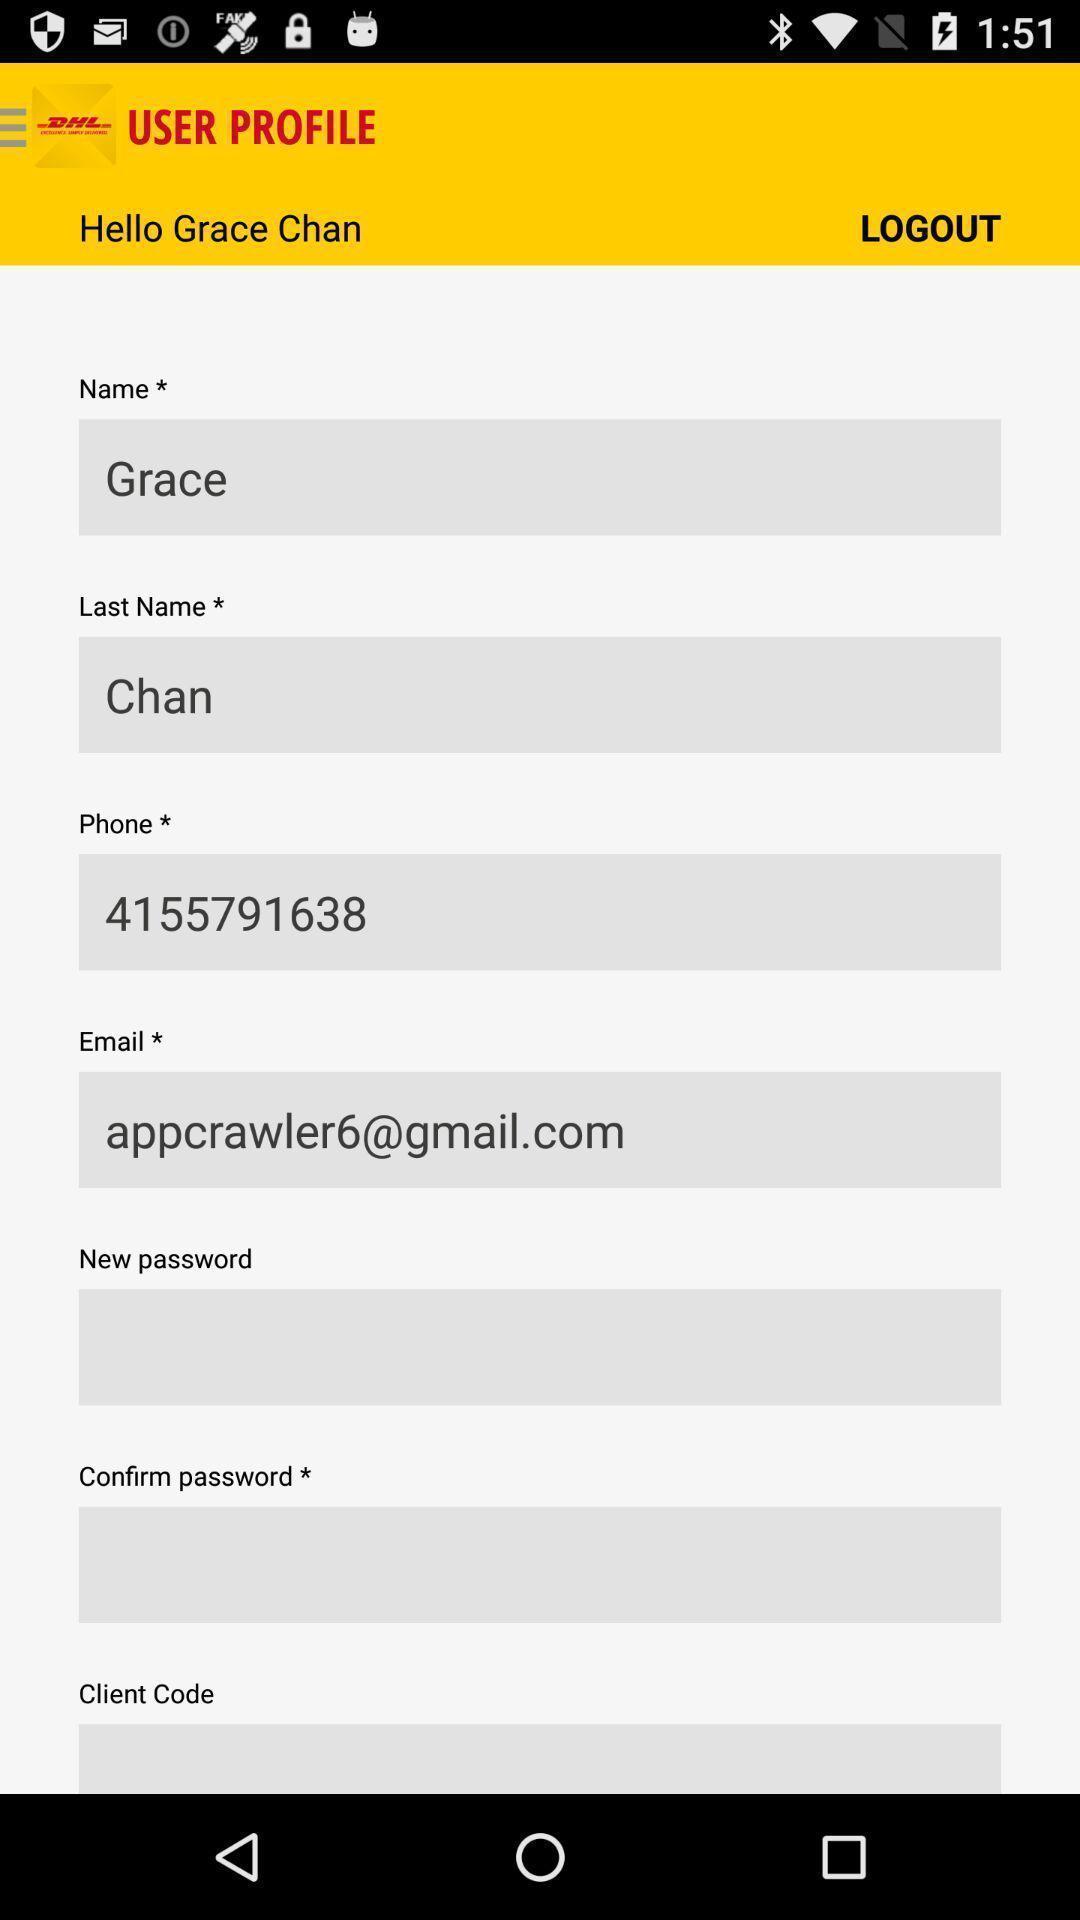Describe the visual elements of this screenshot. Screen showing log out page. 